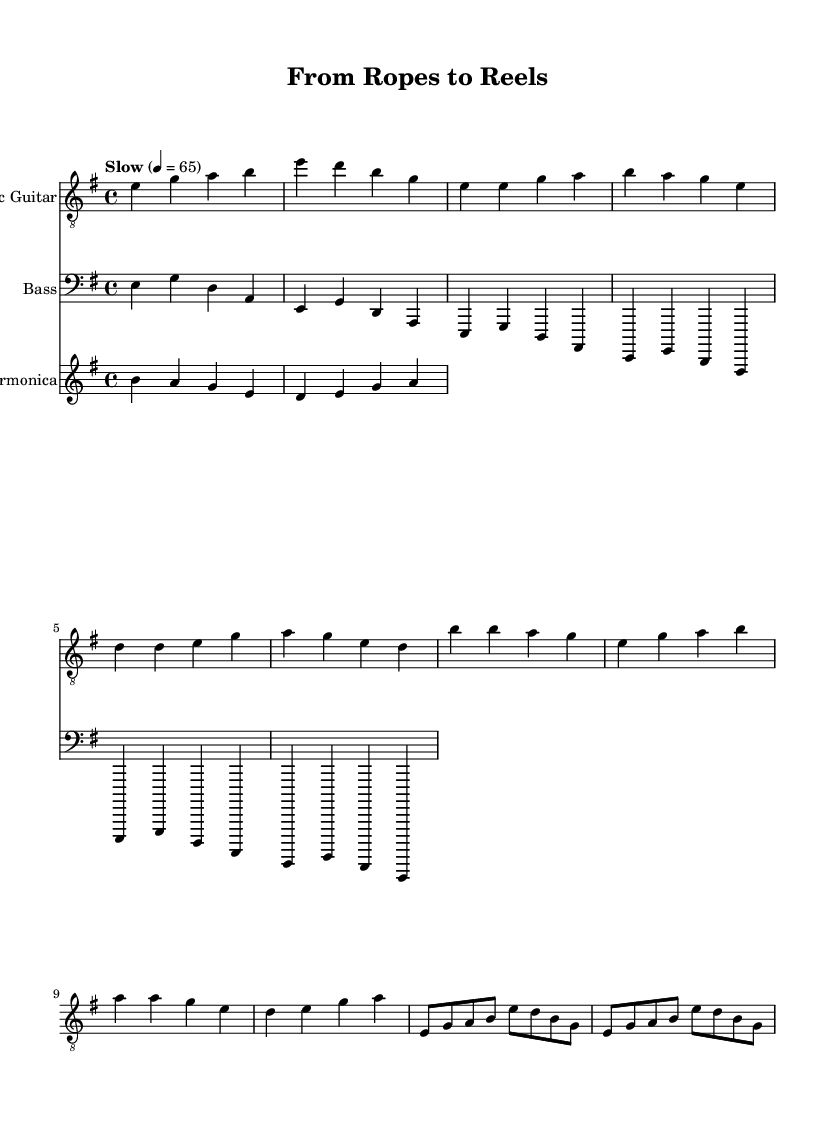What is the key signature of this music? The key signature is indicated at the beginning of the piece and shows two sharps, which represent F# and C#. This confirms that the key is E minor.
Answer: E minor What is the time signature of this music? The time signature is found at the beginning of the sheet music, where it indicates a standard four-beat measure with a "4/4" notation.
Answer: 4/4 What is the tempo marking for this piece? The tempo marking appears in the header of the sheet music and indicates a slow pace, specifically noted as "Slow" with a metronome marking of 65 beats per minute.
Answer: Slow 4 = 65 What is the first note of the electric guitar part? The electric guitar part starts with an E note, which is the first note of the intro section in the score.
Answer: E How many measures are there in the verse section? The verse section consists of 4 measures, which can be counted by observing the notation and layout of the electric guitar part.
Answer: 4 measures How does the chorus differ from the verse in terms of melodic structure? The chorus features a more repetitive structure with some notes being sustained longer (noted with half beats) and a different progression compared to the verse, which has more varied melodic movement.
Answer: Repetitive structure What type of instrument plays the harmonica in this piece? The harmonica is typically categorized as a wind instrument and is denoted in the sheet music with its own staff, indicating its specific role in this electric blues composition.
Answer: Wind instrument 